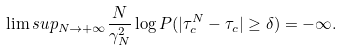<formula> <loc_0><loc_0><loc_500><loc_500>\lim s u p _ { N \rightarrow + \infty } \frac { N } { \gamma _ { N } ^ { 2 } } \log P ( | \tau _ { c } ^ { N } - \tau _ { c } | \geq \delta ) = - \infty .</formula> 